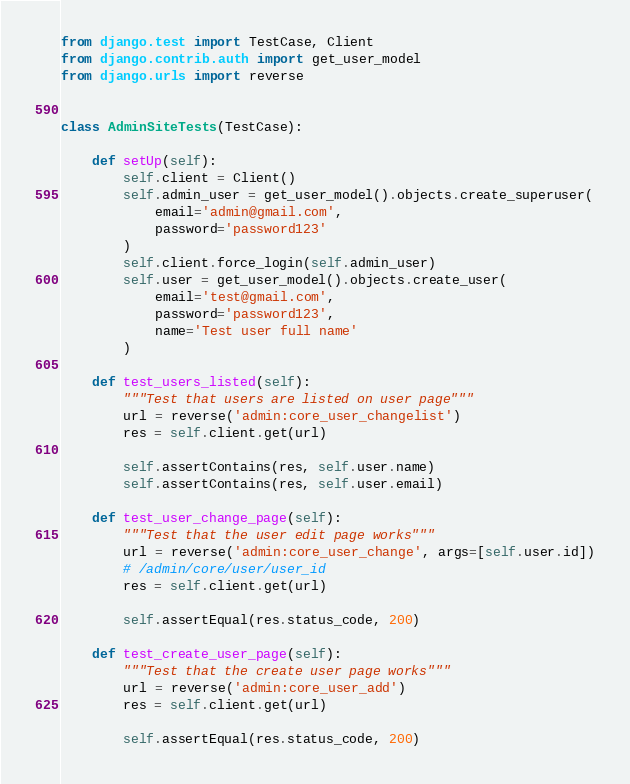<code> <loc_0><loc_0><loc_500><loc_500><_Python_>from django.test import TestCase, Client
from django.contrib.auth import get_user_model
from django.urls import reverse


class AdminSiteTests(TestCase):

    def setUp(self):
        self.client = Client()
        self.admin_user = get_user_model().objects.create_superuser(
            email='admin@gmail.com',
            password='password123'
        )
        self.client.force_login(self.admin_user)
        self.user = get_user_model().objects.create_user(
            email='test@gmail.com',
            password='password123',
            name='Test user full name'
        )

    def test_users_listed(self):
        """Test that users are listed on user page"""
        url = reverse('admin:core_user_changelist')
        res = self.client.get(url)

        self.assertContains(res, self.user.name)
        self.assertContains(res, self.user.email)

    def test_user_change_page(self):
        """Test that the user edit page works"""
        url = reverse('admin:core_user_change', args=[self.user.id])
        # /admin/core/user/user_id
        res = self.client.get(url)

        self.assertEqual(res.status_code, 200)

    def test_create_user_page(self):
        """Test that the create user page works"""
        url = reverse('admin:core_user_add')
        res = self.client.get(url)

        self.assertEqual(res.status_code, 200)
</code> 